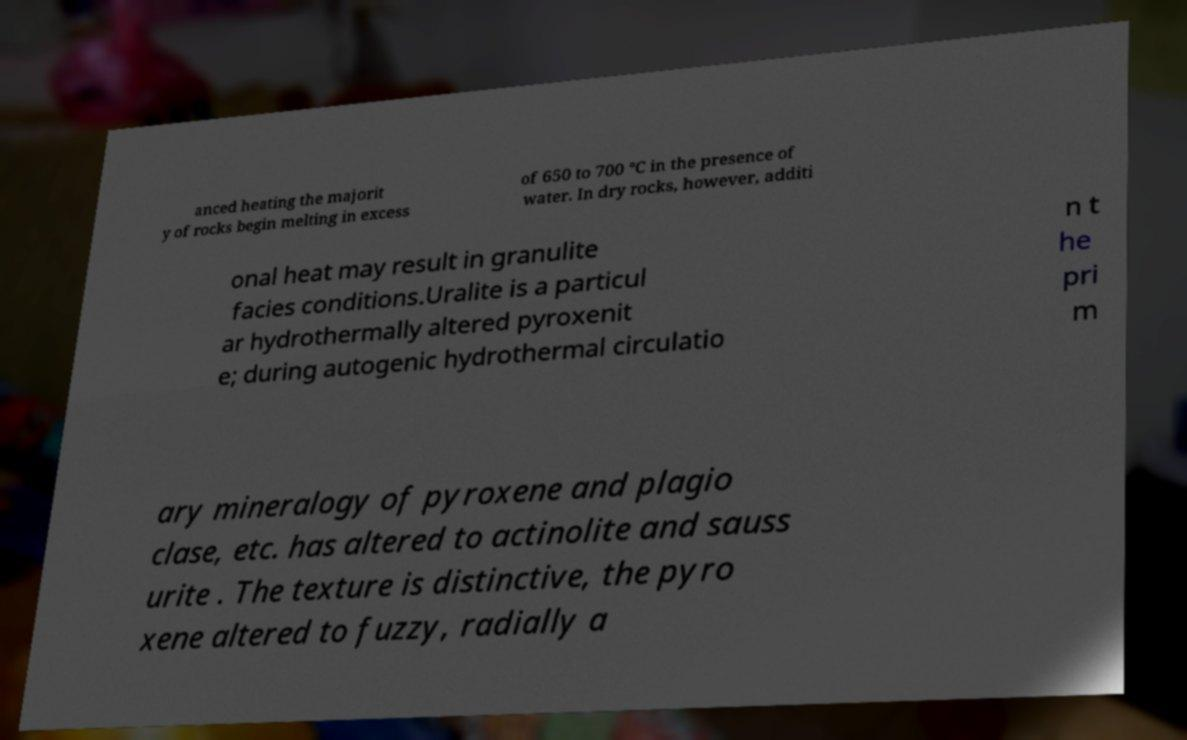For documentation purposes, I need the text within this image transcribed. Could you provide that? anced heating the majorit y of rocks begin melting in excess of 650 to 700 °C in the presence of water. In dry rocks, however, additi onal heat may result in granulite facies conditions.Uralite is a particul ar hydrothermally altered pyroxenit e; during autogenic hydrothermal circulatio n t he pri m ary mineralogy of pyroxene and plagio clase, etc. has altered to actinolite and sauss urite . The texture is distinctive, the pyro xene altered to fuzzy, radially a 